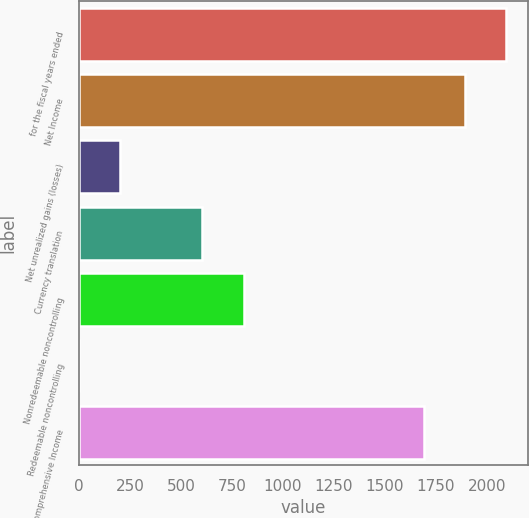Convert chart. <chart><loc_0><loc_0><loc_500><loc_500><bar_chart><fcel>for the fiscal years ended<fcel>Net Income<fcel>Net unrealized gains (losses)<fcel>Currency translation<fcel>Nonredeemable noncontrolling<fcel>Redeemable noncontrolling<fcel>Comprehensive Income<nl><fcel>2096.38<fcel>1894.94<fcel>203.04<fcel>605.92<fcel>807.36<fcel>1.6<fcel>1693.5<nl></chart> 